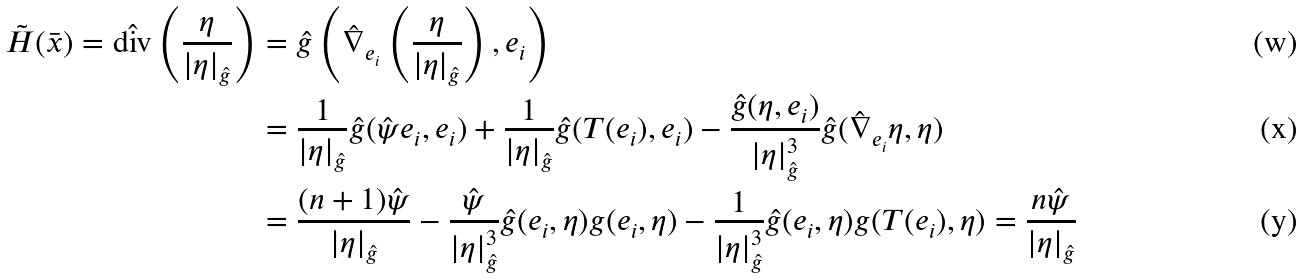<formula> <loc_0><loc_0><loc_500><loc_500>\tilde { H } ( \bar { x } ) = \hat { \text {div} } \left ( \frac { \eta } { | \eta | _ { \hat { g } } } \right ) & = \hat { g } \left ( \hat { \nabla } _ { e _ { i } } \left ( \frac { \eta } { | \eta | _ { \hat { g } } } \right ) , e _ { i } \right ) \\ & = \frac { 1 } { | \eta | _ { \hat { g } } } \hat { g } ( \hat { \psi } e _ { i } , e _ { i } ) + \frac { 1 } { | \eta | _ { \hat { g } } } \hat { g } ( T ( e _ { i } ) , e _ { i } ) - \frac { \hat { g } ( \eta , e _ { i } ) } { | \eta | _ { \hat { g } } ^ { 3 } } \hat { g } ( \hat { \nabla } _ { e _ { i } } \eta , \eta ) \\ & = \frac { ( n + 1 ) \hat { \psi } } { | \eta | _ { \hat { g } } } - \frac { \hat { \psi } } { | \eta | _ { \hat { g } } ^ { 3 } } \hat { g } ( e _ { i } , \eta ) g ( e _ { i } , \eta ) - \frac { 1 } { | \eta | _ { \hat { g } } ^ { 3 } } \hat { g } ( e _ { i } , \eta ) g ( T ( e _ { i } ) , \eta ) = \frac { n \hat { \psi } } { | \eta | _ { \hat { g } } }</formula> 